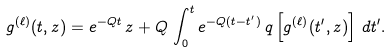<formula> <loc_0><loc_0><loc_500><loc_500>g ^ { ( \ell ) } ( t , z ) = e ^ { - Q t } \, z + Q \, \int _ { 0 } ^ { t } e ^ { - Q ( t - t ^ { \prime } ) } \, q \left [ g ^ { ( \ell ) } ( t ^ { \prime } , z ) \right ] \, d t ^ { \prime } .</formula> 